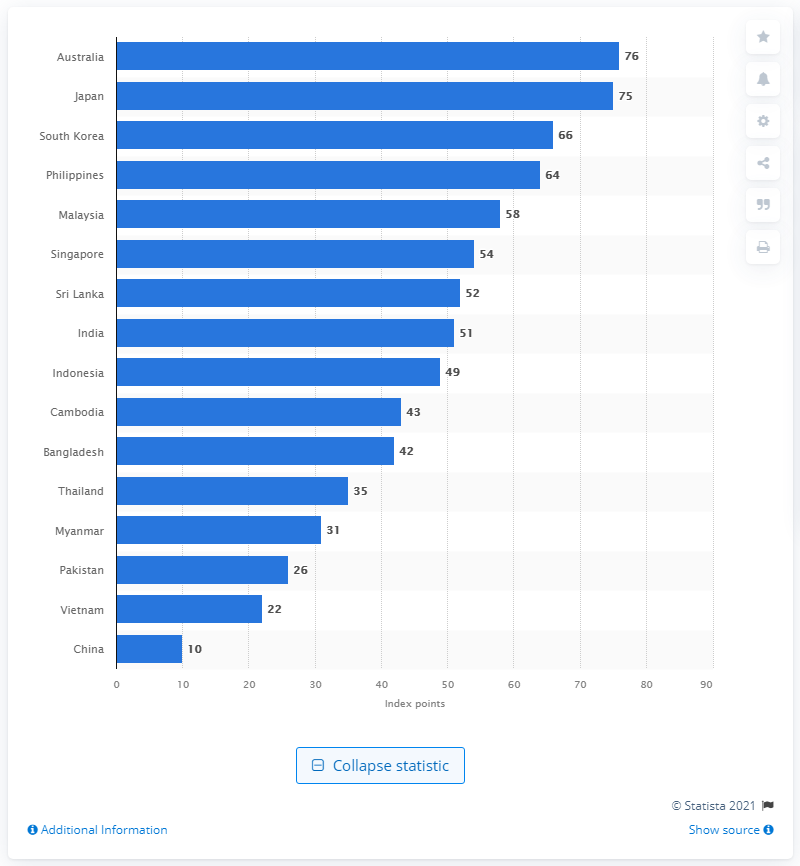Highlight a few significant elements in this photo. According to the report released in 2020, Australia was ranked as the country with the highest degree of internet freedom. In 2020, Australia scored 76 out of 100 possible index points in terms of internet freedom, indicating a moderate level of internet freedom in the country. In 2020, China scored 10 index points in terms of internet freedom, making it the country with the highest score in this category. 